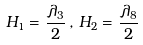Convert formula to latex. <formula><loc_0><loc_0><loc_500><loc_500>H _ { 1 } = \frac { \lambda _ { 3 } } { 2 } \, , \, H _ { 2 } = \frac { \lambda _ { 8 } } { 2 }</formula> 